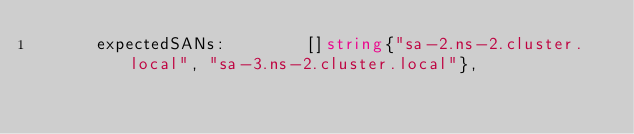Convert code to text. <code><loc_0><loc_0><loc_500><loc_500><_Go_>			expectedSANs:        []string{"sa-2.ns-2.cluster.local", "sa-3.ns-2.cluster.local"},</code> 